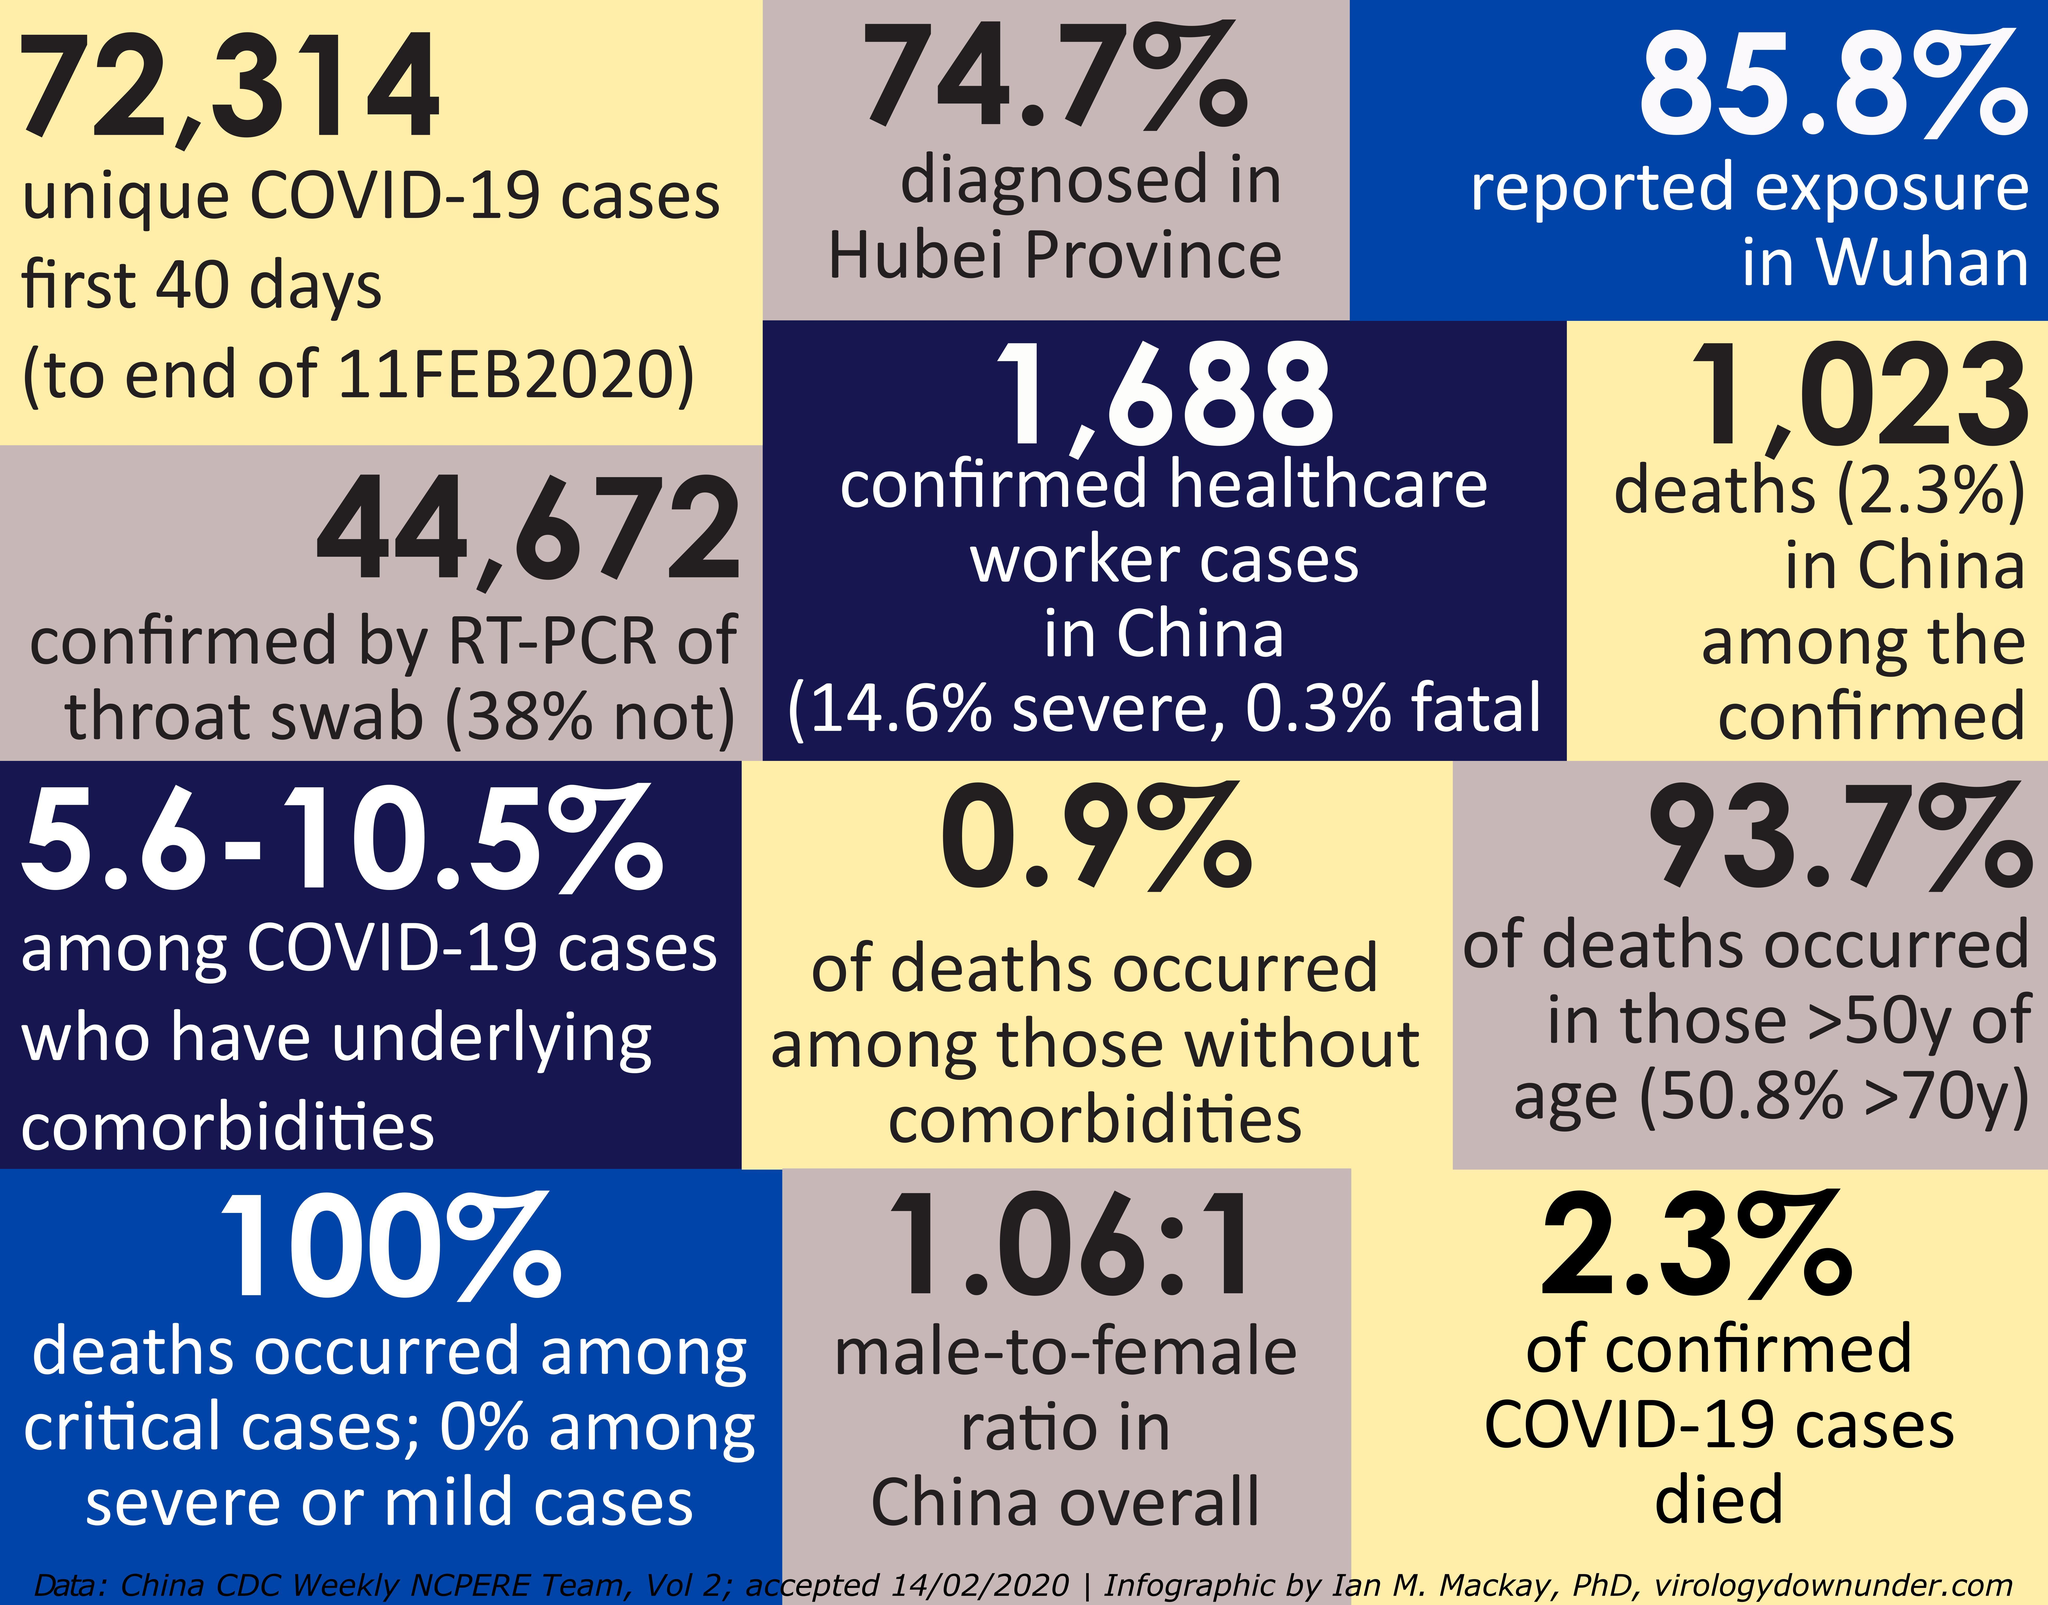What percent of cases have not been confirmed by RT-PCR of throat swab?
Answer the question with a short phrase. 38% What percent of confirmed COVID-19 cases survived? 97.7% What percent of exposure has not been reported in Wuhan? 14.2% 